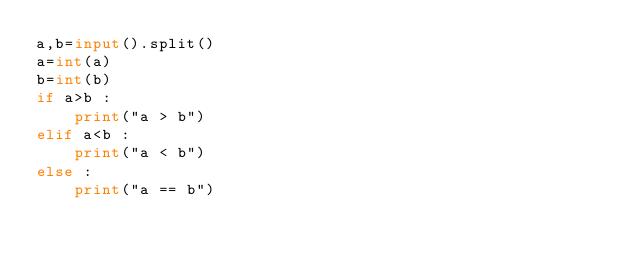Convert code to text. <code><loc_0><loc_0><loc_500><loc_500><_Python_>a,b=input().split()
a=int(a)
b=int(b)
if a>b :
    print("a > b")
elif a<b :
    print("a < b")
else :
    print("a == b")
</code> 